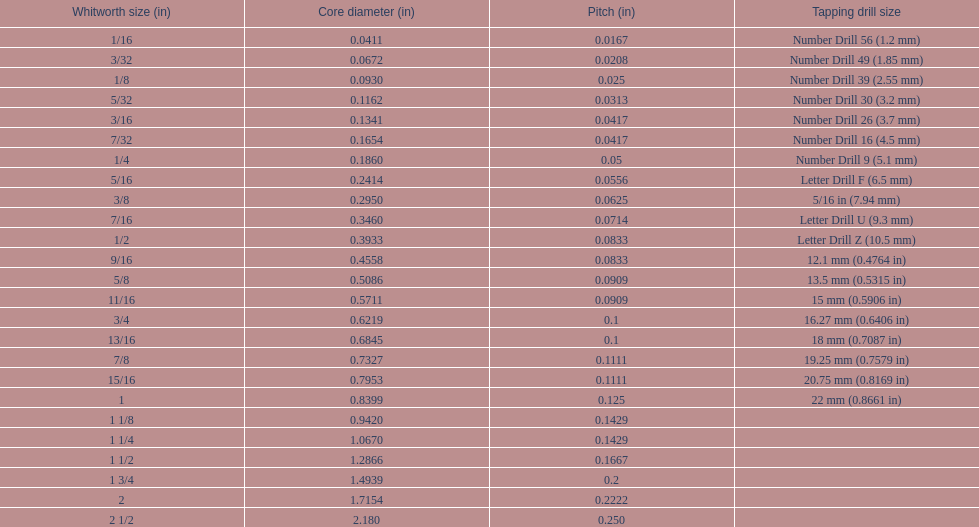What is the total of the first two core diameters? 0.1083. 